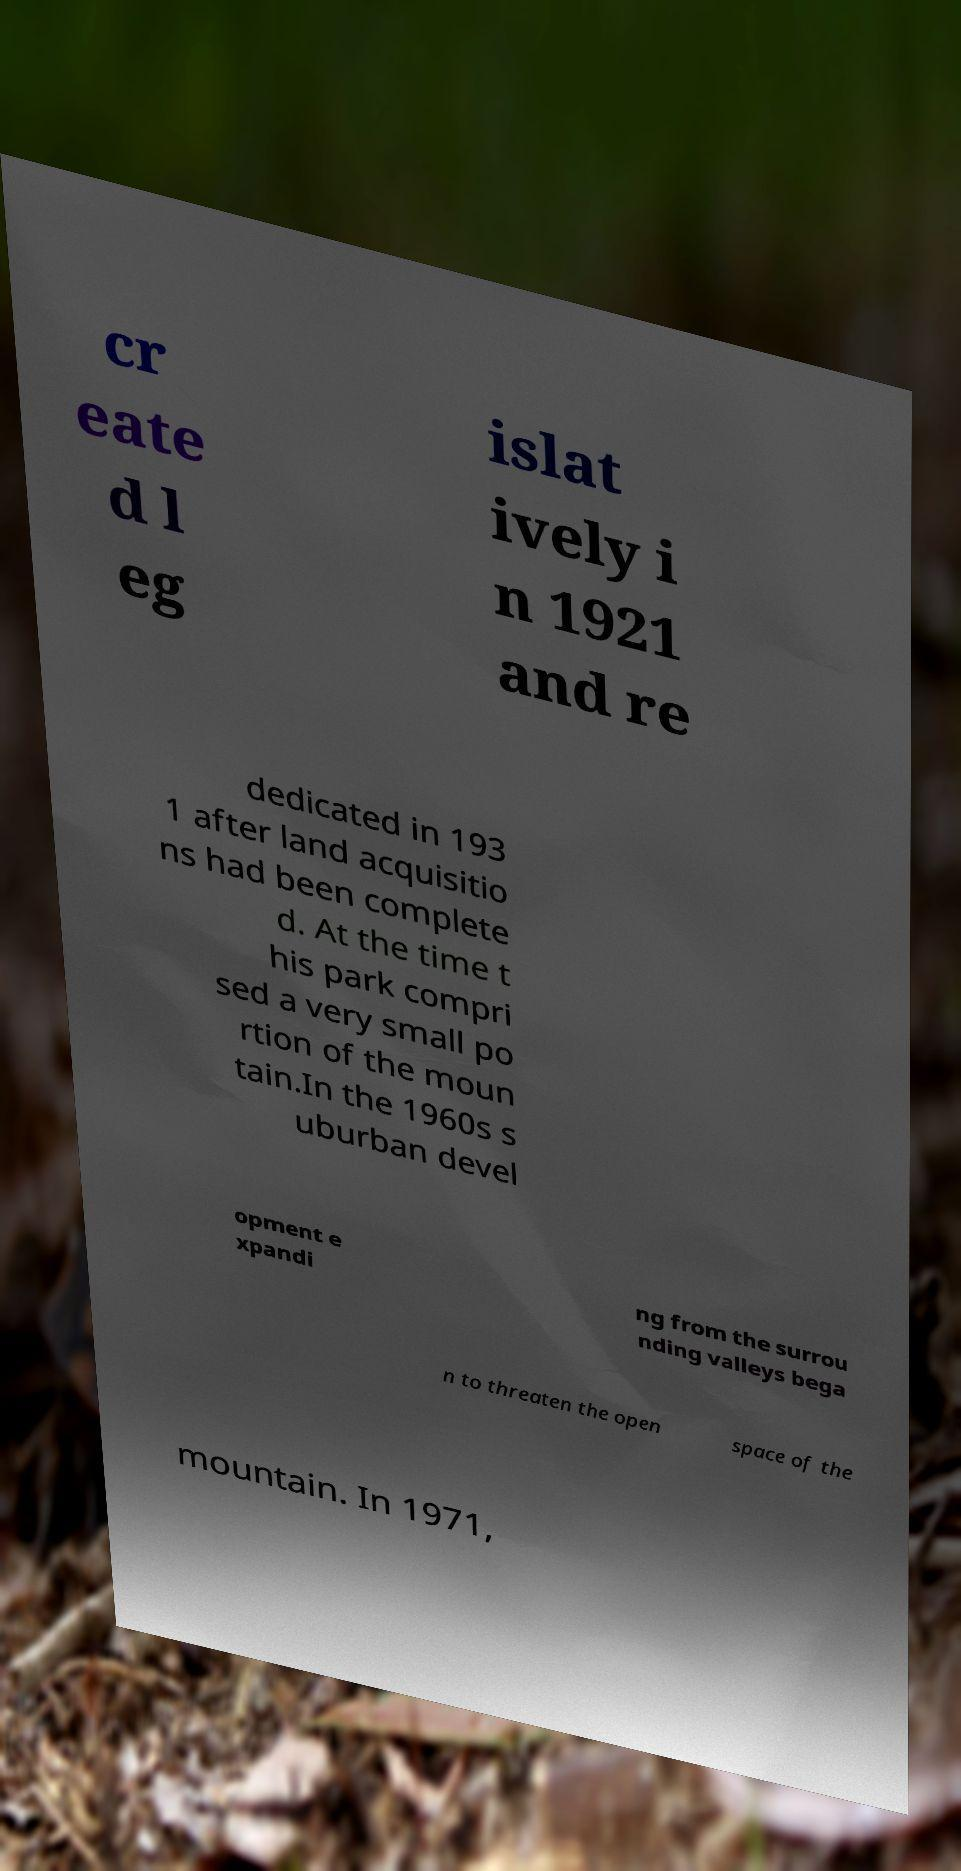What messages or text are displayed in this image? I need them in a readable, typed format. cr eate d l eg islat ively i n 1921 and re dedicated in 193 1 after land acquisitio ns had been complete d. At the time t his park compri sed a very small po rtion of the moun tain.In the 1960s s uburban devel opment e xpandi ng from the surrou nding valleys bega n to threaten the open space of the mountain. In 1971, 